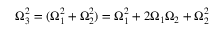<formula> <loc_0><loc_0><loc_500><loc_500>\Omega _ { 3 } ^ { 2 } = ( \Omega _ { 1 } ^ { 2 } + \Omega _ { 2 } ^ { 2 } ) = \Omega _ { 1 } ^ { 2 } + 2 \Omega _ { 1 } \Omega _ { 2 } + \Omega _ { 2 } ^ { 2 }</formula> 